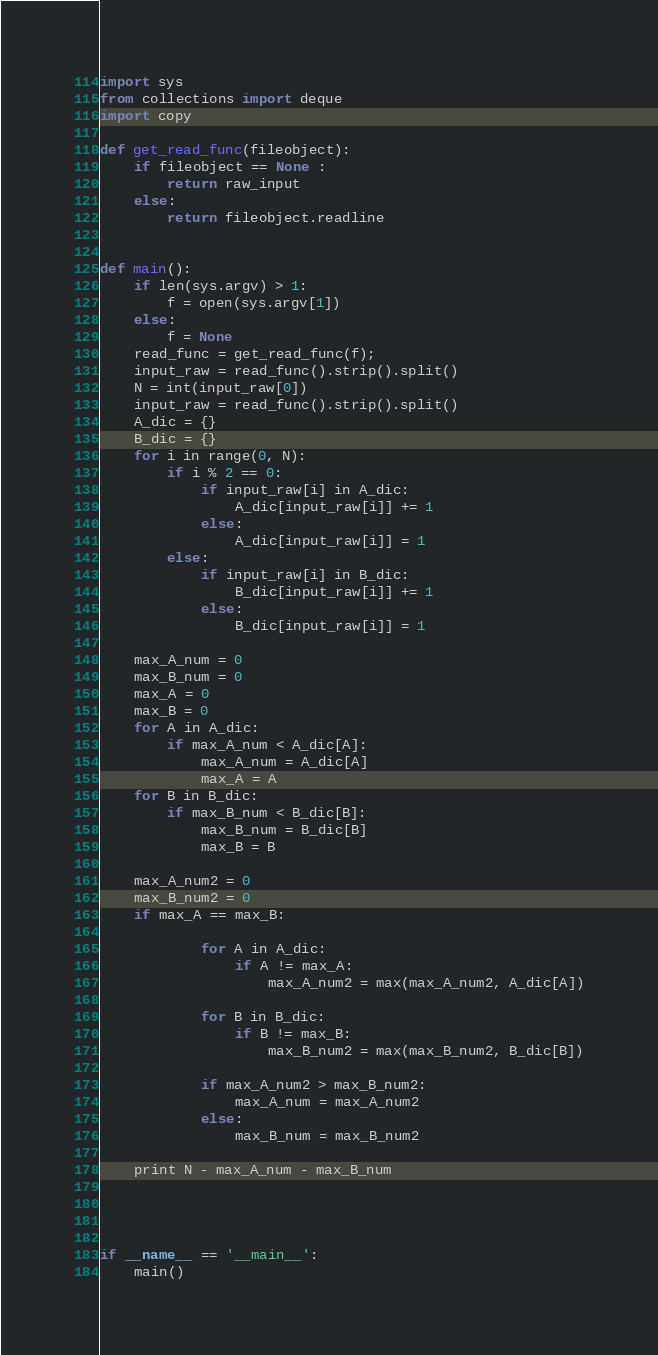<code> <loc_0><loc_0><loc_500><loc_500><_Python_>import sys
from collections import deque
import copy

def get_read_func(fileobject):
    if fileobject == None :
        return raw_input
    else:
        return fileobject.readline


def main():
    if len(sys.argv) > 1:
        f = open(sys.argv[1])
    else:
        f = None
    read_func = get_read_func(f);
    input_raw = read_func().strip().split()
    N = int(input_raw[0])
    input_raw = read_func().strip().split()
    A_dic = {}
    B_dic = {}
    for i in range(0, N):
        if i % 2 == 0:
            if input_raw[i] in A_dic:
                A_dic[input_raw[i]] += 1
            else:
                A_dic[input_raw[i]] = 1
        else:
            if input_raw[i] in B_dic:
                B_dic[input_raw[i]] += 1
            else:
                B_dic[input_raw[i]] = 1

    max_A_num = 0
    max_B_num = 0
    max_A = 0
    max_B = 0
    for A in A_dic:
        if max_A_num < A_dic[A]:
            max_A_num = A_dic[A]
            max_A = A
    for B in B_dic:
        if max_B_num < B_dic[B]:
            max_B_num = B_dic[B]
            max_B = B

    max_A_num2 = 0
    max_B_num2 = 0
    if max_A == max_B:

            for A in A_dic:
                if A != max_A:
                    max_A_num2 = max(max_A_num2, A_dic[A])

            for B in B_dic:
                if B != max_B:
                    max_B_num2 = max(max_B_num2, B_dic[B])

            if max_A_num2 > max_B_num2:
                max_A_num = max_A_num2
            else:
                max_B_num = max_B_num2

    print N - max_A_num - max_B_num




if __name__ == '__main__':
    main()
</code> 